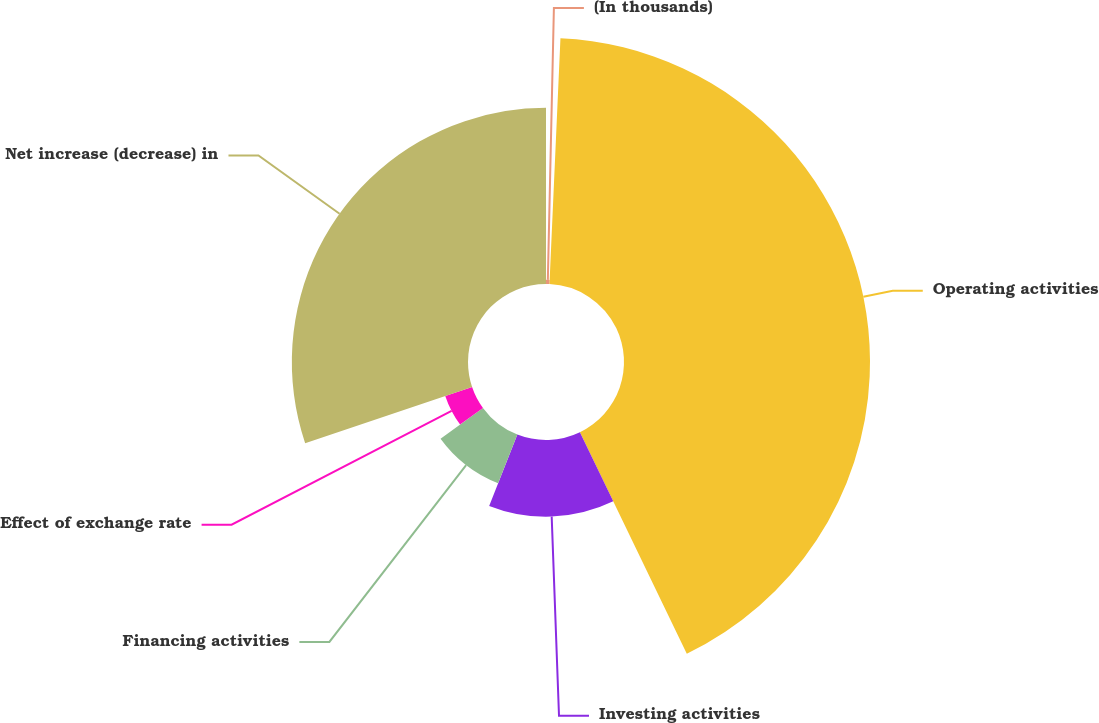Convert chart to OTSL. <chart><loc_0><loc_0><loc_500><loc_500><pie_chart><fcel>(In thousands)<fcel>Operating activities<fcel>Investing activities<fcel>Financing activities<fcel>Effect of exchange rate<fcel>Net increase (decrease) in<nl><fcel>0.71%<fcel>42.13%<fcel>13.14%<fcel>8.99%<fcel>4.85%<fcel>30.17%<nl></chart> 